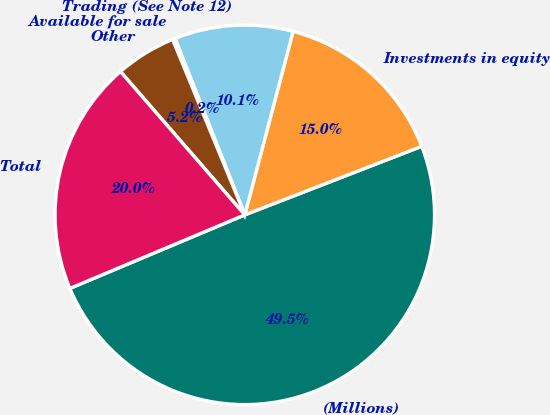Convert chart. <chart><loc_0><loc_0><loc_500><loc_500><pie_chart><fcel>(Millions)<fcel>Investments in equity<fcel>Trading (See Note 12)<fcel>Available for sale<fcel>Other<fcel>Total<nl><fcel>49.55%<fcel>15.02%<fcel>10.09%<fcel>0.22%<fcel>5.16%<fcel>19.96%<nl></chart> 